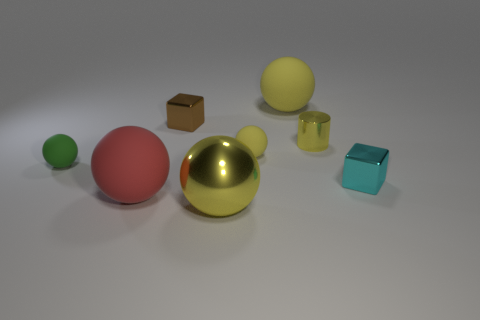How many yellow balls must be subtracted to get 1 yellow balls? 2 Subtract all green cubes. How many yellow spheres are left? 3 Subtract all tiny green matte balls. How many balls are left? 4 Subtract all green spheres. How many spheres are left? 4 Subtract all brown spheres. Subtract all red blocks. How many spheres are left? 5 Add 2 brown shiny cubes. How many objects exist? 10 Subtract all cubes. How many objects are left? 6 Add 4 brown objects. How many brown objects are left? 5 Add 3 cyan cylinders. How many cyan cylinders exist? 3 Subtract 1 cyan cubes. How many objects are left? 7 